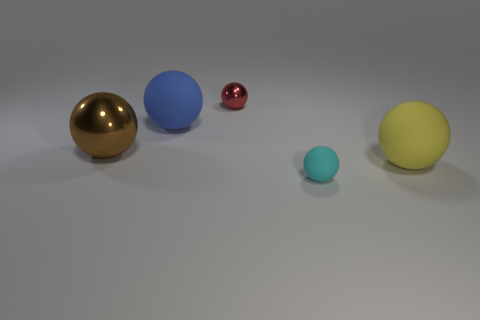Subtract all blue balls. How many balls are left? 4 Subtract 4 spheres. How many spheres are left? 1 Subtract all brown spheres. How many spheres are left? 4 Add 2 large yellow rubber objects. How many objects exist? 7 Subtract 0 red blocks. How many objects are left? 5 Subtract all red spheres. Subtract all blue cubes. How many spheres are left? 4 Subtract all green cubes. How many blue spheres are left? 1 Subtract all tiny red metal cylinders. Subtract all large yellow matte spheres. How many objects are left? 4 Add 5 red shiny things. How many red shiny things are left? 6 Add 4 tiny green metallic spheres. How many tiny green metallic spheres exist? 4 